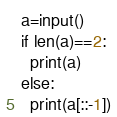<code> <loc_0><loc_0><loc_500><loc_500><_Python_>a=input()
if len(a)==2:
  print(a)
else:
  print(a[::-1])</code> 